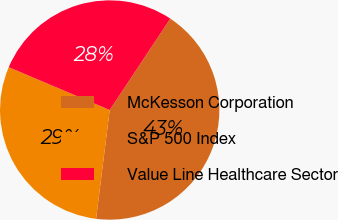Convert chart to OTSL. <chart><loc_0><loc_0><loc_500><loc_500><pie_chart><fcel>McKesson Corporation<fcel>S&P 500 Index<fcel>Value Line Healthcare Sector<nl><fcel>42.66%<fcel>29.4%<fcel>27.93%<nl></chart> 